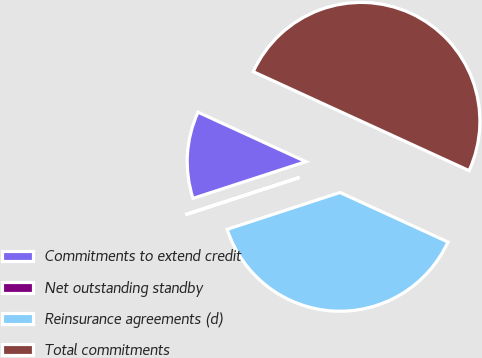<chart> <loc_0><loc_0><loc_500><loc_500><pie_chart><fcel>Commitments to extend credit<fcel>Net outstanding standby<fcel>Reinsurance agreements (d)<fcel>Total commitments<nl><fcel>11.85%<fcel>0.02%<fcel>38.13%<fcel>50.0%<nl></chart> 